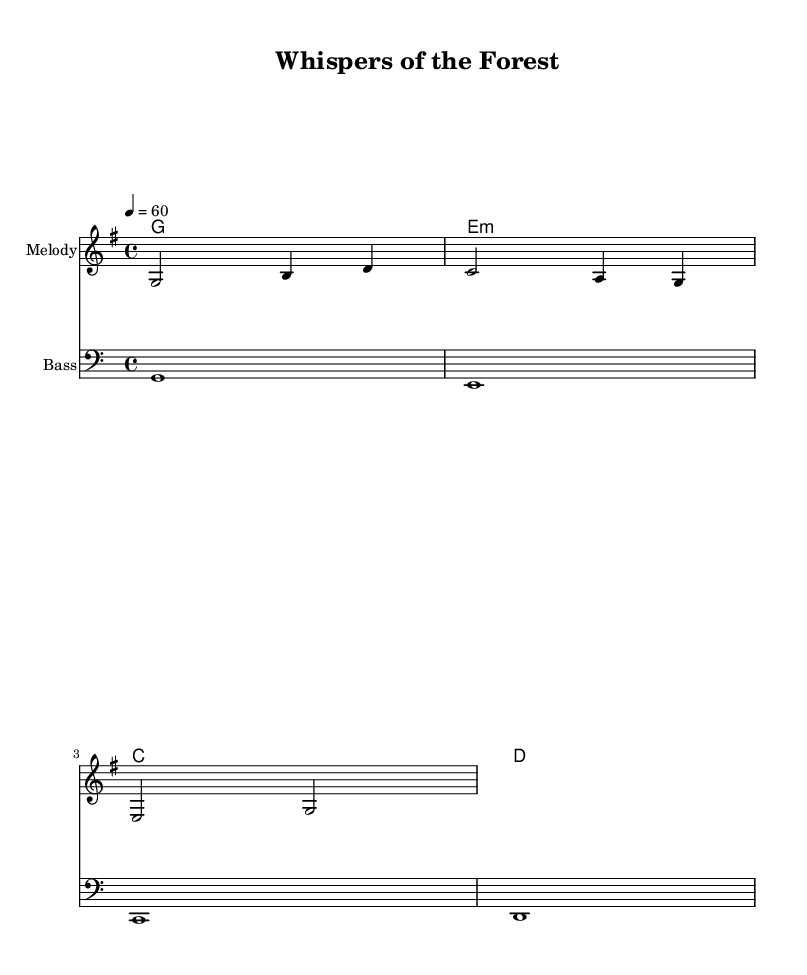What is the key signature of this music? The key signature is G major, which has one sharp (F#). This can be identified by looking at the initial part of the sheet music where the key signature is indicated.
Answer: G major What is the time signature of this music? The time signature is 4/4, which is indicated at the beginning of the score. It means there are four beats per measure, and the quarter note gets one beat.
Answer: 4/4 What is the tempo marking for this piece? The tempo marking is 60 beats per minute, specified by the instruction "4 = 60" at the start of the score. This indicates that a quarter note gets 60 beats in a minute.
Answer: 60 How many measures are in the melody? The melody consists of 3 measures, as counted from the notation indicated in the score. Each group of notes separated by the vertical lines represents a measure.
Answer: 3 What type of music fusion does this piece represent? This piece represents a gentle folk-electronic fusion lullaby, which incorporates nature sounds and has a relaxing theme. It is characterized by its calm melody and soothing harmonies.
Answer: Folk-electronic fusion Which instrument is indicated for the melody? The instrument indicated for the melody is simply labeled as "Melody" in the staff notation. This tells us that this part is meant to be played as the lead melodic line.
Answer: Melody What are the chord changes indicated at the beginning? The chord changes indicated at the beginning are G, E minor, C, and D, which appear in the chord names section and inform players of the harmonic progression to be followed throughout the piece.
Answer: G, E minor, C, D 